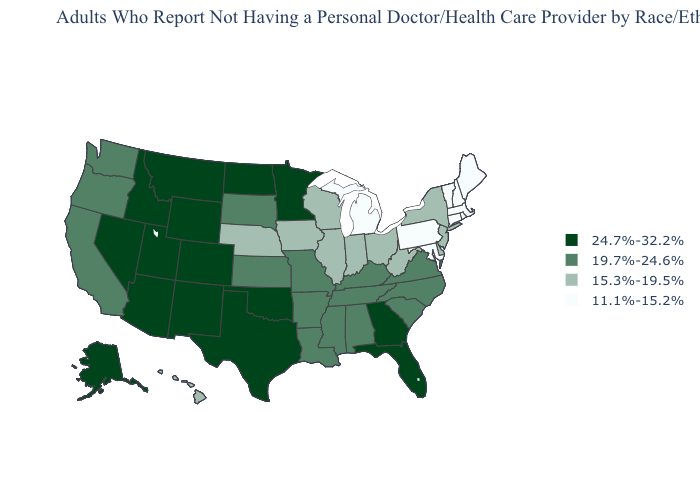Is the legend a continuous bar?
Write a very short answer. No. What is the value of Texas?
Be succinct. 24.7%-32.2%. Does Louisiana have the same value as North Carolina?
Short answer required. Yes. What is the value of Michigan?
Concise answer only. 11.1%-15.2%. Does the map have missing data?
Give a very brief answer. No. What is the highest value in the MidWest ?
Short answer required. 24.7%-32.2%. Does Oklahoma have the same value as North Carolina?
Give a very brief answer. No. What is the highest value in states that border South Carolina?
Give a very brief answer. 24.7%-32.2%. Among the states that border New Hampshire , which have the lowest value?
Be succinct. Maine, Massachusetts, Vermont. Name the states that have a value in the range 11.1%-15.2%?
Answer briefly. Connecticut, Maine, Maryland, Massachusetts, Michigan, New Hampshire, Pennsylvania, Rhode Island, Vermont. Among the states that border Alabama , does Tennessee have the lowest value?
Write a very short answer. Yes. Among the states that border Louisiana , does Texas have the lowest value?
Keep it brief. No. What is the value of Oklahoma?
Answer briefly. 24.7%-32.2%. What is the value of Pennsylvania?
Write a very short answer. 11.1%-15.2%. 